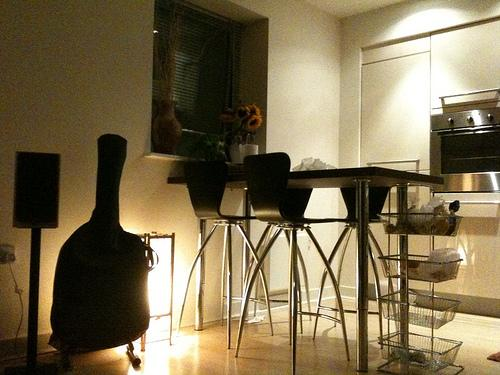What kind of musical instrument is covered by the guitar on the left side of the room? Please explain your reasoning. guitar. There is a guitar covered up by a wrapping on the left side. 